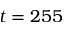Convert formula to latex. <formula><loc_0><loc_0><loc_500><loc_500>t = 2 5 5</formula> 